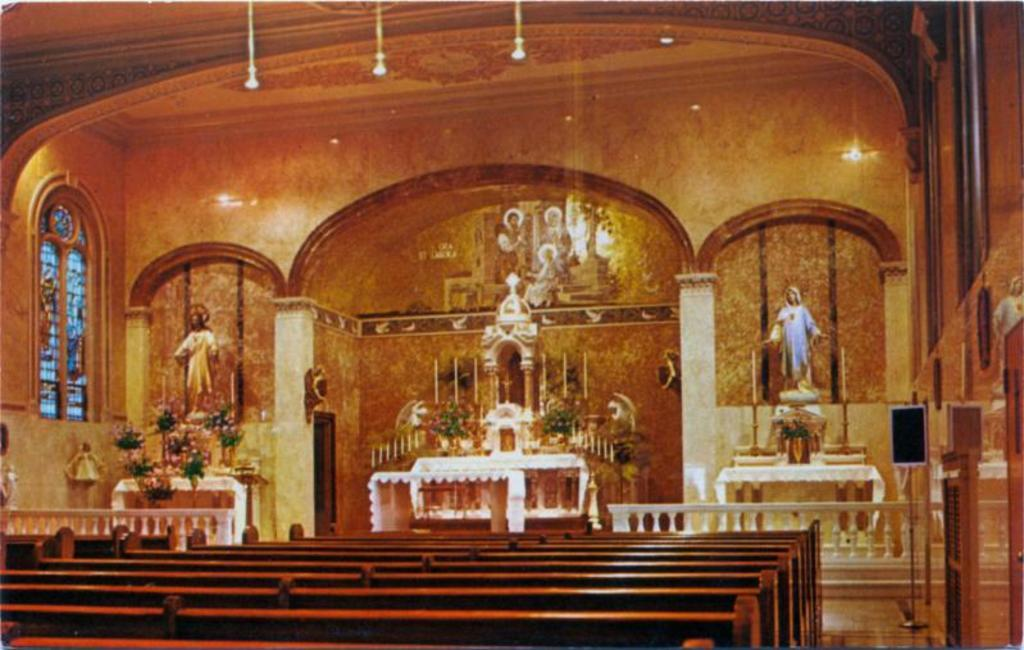Where is the image taken? The image is inside a church. What type of seating is available in the church? There are benches in the image. Are there any decorations on display in the image? Yes, there are flower bouquets on a table in the image. What religious figures or symbols might be present in the church? There are statues in the image. Are there any sources of light in the image? Yes, there are candles and lights in the image. What architectural feature allows natural light to enter the church? There are windows in the image. What type of straw is used to make the cub in the image? There is no straw or cub present in the image. What type of brush is used to clean the windows in the image? There is no mention of a brush or window cleaning in the image. 